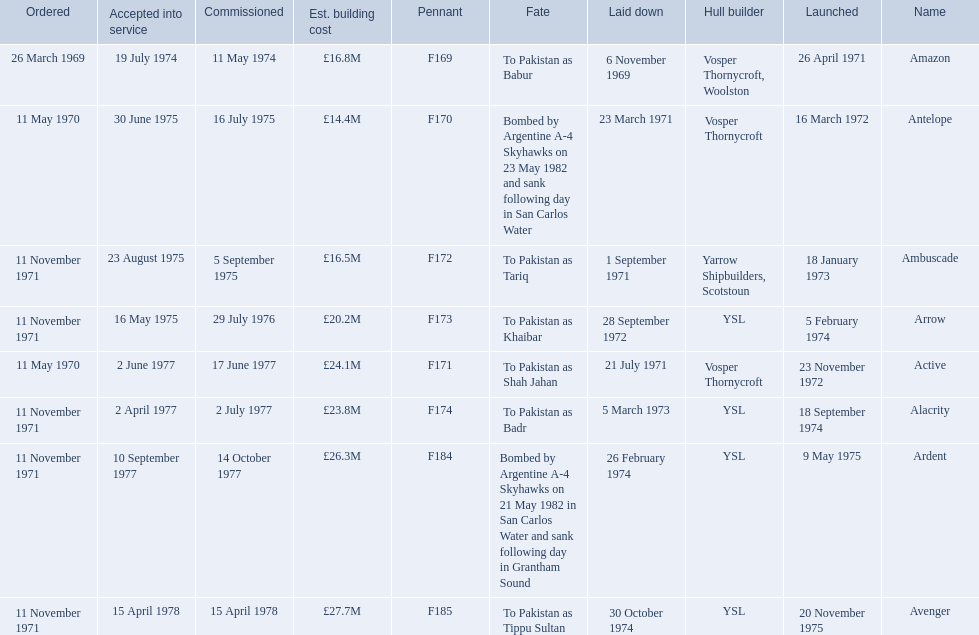What were the estimated building costs of the frigates? £16.8M, £14.4M, £16.5M, £20.2M, £24.1M, £23.8M, £26.3M, £27.7M. Which of these is the largest? £27.7M. What ship name does that correspond to? Avenger. 